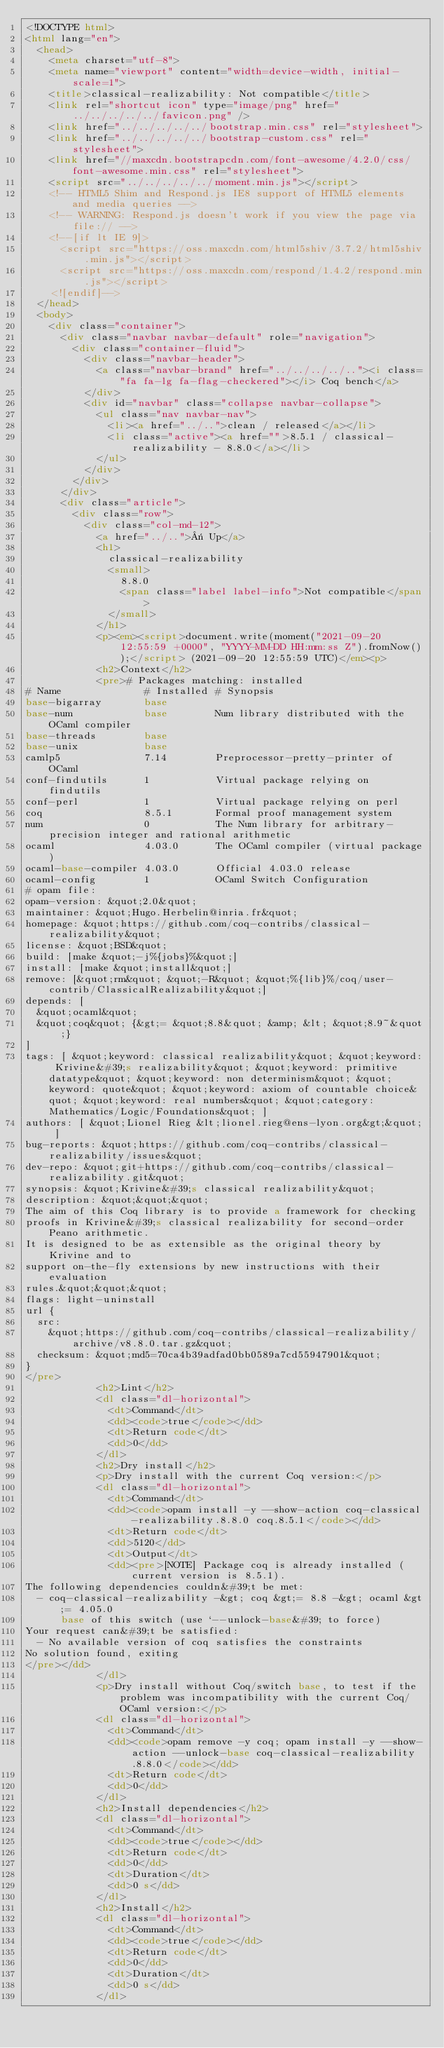<code> <loc_0><loc_0><loc_500><loc_500><_HTML_><!DOCTYPE html>
<html lang="en">
  <head>
    <meta charset="utf-8">
    <meta name="viewport" content="width=device-width, initial-scale=1">
    <title>classical-realizability: Not compatible</title>
    <link rel="shortcut icon" type="image/png" href="../../../../../favicon.png" />
    <link href="../../../../../bootstrap.min.css" rel="stylesheet">
    <link href="../../../../../bootstrap-custom.css" rel="stylesheet">
    <link href="//maxcdn.bootstrapcdn.com/font-awesome/4.2.0/css/font-awesome.min.css" rel="stylesheet">
    <script src="../../../../../moment.min.js"></script>
    <!-- HTML5 Shim and Respond.js IE8 support of HTML5 elements and media queries -->
    <!-- WARNING: Respond.js doesn't work if you view the page via file:// -->
    <!--[if lt IE 9]>
      <script src="https://oss.maxcdn.com/html5shiv/3.7.2/html5shiv.min.js"></script>
      <script src="https://oss.maxcdn.com/respond/1.4.2/respond.min.js"></script>
    <![endif]-->
  </head>
  <body>
    <div class="container">
      <div class="navbar navbar-default" role="navigation">
        <div class="container-fluid">
          <div class="navbar-header">
            <a class="navbar-brand" href="../../../../.."><i class="fa fa-lg fa-flag-checkered"></i> Coq bench</a>
          </div>
          <div id="navbar" class="collapse navbar-collapse">
            <ul class="nav navbar-nav">
              <li><a href="../..">clean / released</a></li>
              <li class="active"><a href="">8.5.1 / classical-realizability - 8.8.0</a></li>
            </ul>
          </div>
        </div>
      </div>
      <div class="article">
        <div class="row">
          <div class="col-md-12">
            <a href="../..">« Up</a>
            <h1>
              classical-realizability
              <small>
                8.8.0
                <span class="label label-info">Not compatible</span>
              </small>
            </h1>
            <p><em><script>document.write(moment("2021-09-20 12:55:59 +0000", "YYYY-MM-DD HH:mm:ss Z").fromNow());</script> (2021-09-20 12:55:59 UTC)</em><p>
            <h2>Context</h2>
            <pre># Packages matching: installed
# Name              # Installed # Synopsis
base-bigarray       base
base-num            base        Num library distributed with the OCaml compiler
base-threads        base
base-unix           base
camlp5              7.14        Preprocessor-pretty-printer of OCaml
conf-findutils      1           Virtual package relying on findutils
conf-perl           1           Virtual package relying on perl
coq                 8.5.1       Formal proof management system
num                 0           The Num library for arbitrary-precision integer and rational arithmetic
ocaml               4.03.0      The OCaml compiler (virtual package)
ocaml-base-compiler 4.03.0      Official 4.03.0 release
ocaml-config        1           OCaml Switch Configuration
# opam file:
opam-version: &quot;2.0&quot;
maintainer: &quot;Hugo.Herbelin@inria.fr&quot;
homepage: &quot;https://github.com/coq-contribs/classical-realizability&quot;
license: &quot;BSD&quot;
build: [make &quot;-j%{jobs}%&quot;]
install: [make &quot;install&quot;]
remove: [&quot;rm&quot; &quot;-R&quot; &quot;%{lib}%/coq/user-contrib/ClassicalRealizability&quot;]
depends: [
  &quot;ocaml&quot;
  &quot;coq&quot; {&gt;= &quot;8.8&quot; &amp; &lt; &quot;8.9~&quot;}
]
tags: [ &quot;keyword: classical realizability&quot; &quot;keyword: Krivine&#39;s realizability&quot; &quot;keyword: primitive datatype&quot; &quot;keyword: non determinism&quot; &quot;keyword: quote&quot; &quot;keyword: axiom of countable choice&quot; &quot;keyword: real numbers&quot; &quot;category: Mathematics/Logic/Foundations&quot; ]
authors: [ &quot;Lionel Rieg &lt;lionel.rieg@ens-lyon.org&gt;&quot; ]
bug-reports: &quot;https://github.com/coq-contribs/classical-realizability/issues&quot;
dev-repo: &quot;git+https://github.com/coq-contribs/classical-realizability.git&quot;
synopsis: &quot;Krivine&#39;s classical realizability&quot;
description: &quot;&quot;&quot;
The aim of this Coq library is to provide a framework for checking
proofs in Krivine&#39;s classical realizability for second-order Peano arithmetic.
It is designed to be as extensible as the original theory by Krivine and to
support on-the-fly extensions by new instructions with their evaluation
rules.&quot;&quot;&quot;
flags: light-uninstall
url {
  src:
    &quot;https://github.com/coq-contribs/classical-realizability/archive/v8.8.0.tar.gz&quot;
  checksum: &quot;md5=70ca4b39adfad0bb0589a7cd55947901&quot;
}
</pre>
            <h2>Lint</h2>
            <dl class="dl-horizontal">
              <dt>Command</dt>
              <dd><code>true</code></dd>
              <dt>Return code</dt>
              <dd>0</dd>
            </dl>
            <h2>Dry install</h2>
            <p>Dry install with the current Coq version:</p>
            <dl class="dl-horizontal">
              <dt>Command</dt>
              <dd><code>opam install -y --show-action coq-classical-realizability.8.8.0 coq.8.5.1</code></dd>
              <dt>Return code</dt>
              <dd>5120</dd>
              <dt>Output</dt>
              <dd><pre>[NOTE] Package coq is already installed (current version is 8.5.1).
The following dependencies couldn&#39;t be met:
  - coq-classical-realizability -&gt; coq &gt;= 8.8 -&gt; ocaml &gt;= 4.05.0
      base of this switch (use `--unlock-base&#39; to force)
Your request can&#39;t be satisfied:
  - No available version of coq satisfies the constraints
No solution found, exiting
</pre></dd>
            </dl>
            <p>Dry install without Coq/switch base, to test if the problem was incompatibility with the current Coq/OCaml version:</p>
            <dl class="dl-horizontal">
              <dt>Command</dt>
              <dd><code>opam remove -y coq; opam install -y --show-action --unlock-base coq-classical-realizability.8.8.0</code></dd>
              <dt>Return code</dt>
              <dd>0</dd>
            </dl>
            <h2>Install dependencies</h2>
            <dl class="dl-horizontal">
              <dt>Command</dt>
              <dd><code>true</code></dd>
              <dt>Return code</dt>
              <dd>0</dd>
              <dt>Duration</dt>
              <dd>0 s</dd>
            </dl>
            <h2>Install</h2>
            <dl class="dl-horizontal">
              <dt>Command</dt>
              <dd><code>true</code></dd>
              <dt>Return code</dt>
              <dd>0</dd>
              <dt>Duration</dt>
              <dd>0 s</dd>
            </dl></code> 